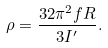<formula> <loc_0><loc_0><loc_500><loc_500>\rho = \frac { 3 2 \pi ^ { 2 } f R } { 3 I ^ { \prime } } .</formula> 